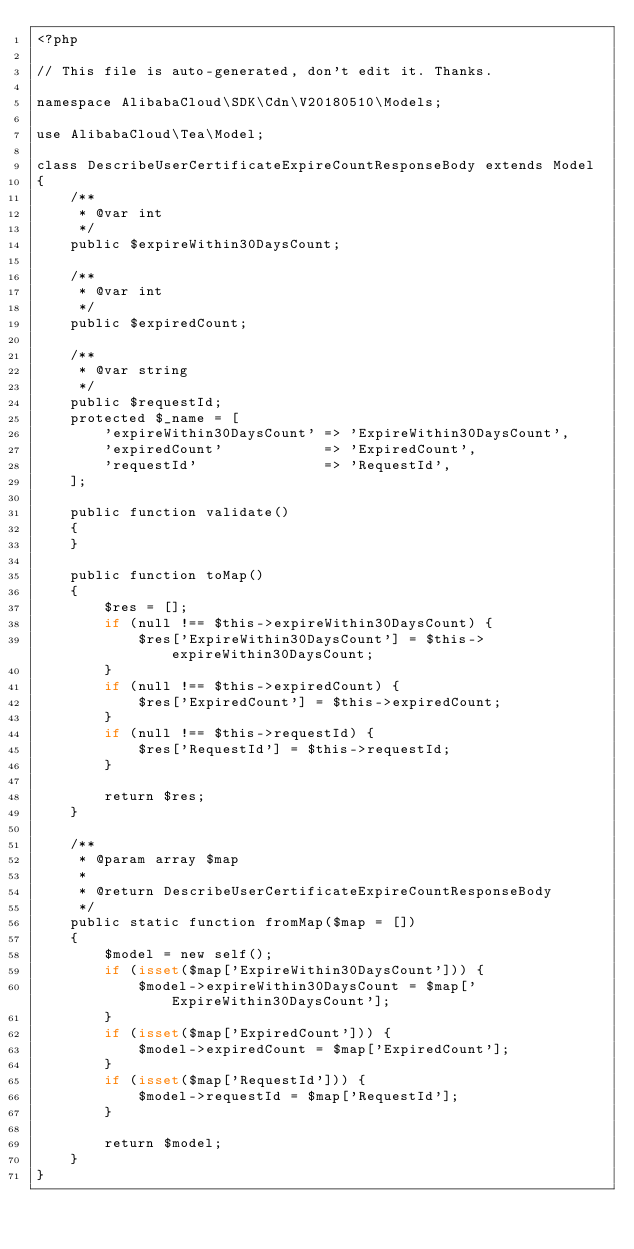<code> <loc_0><loc_0><loc_500><loc_500><_PHP_><?php

// This file is auto-generated, don't edit it. Thanks.

namespace AlibabaCloud\SDK\Cdn\V20180510\Models;

use AlibabaCloud\Tea\Model;

class DescribeUserCertificateExpireCountResponseBody extends Model
{
    /**
     * @var int
     */
    public $expireWithin30DaysCount;

    /**
     * @var int
     */
    public $expiredCount;

    /**
     * @var string
     */
    public $requestId;
    protected $_name = [
        'expireWithin30DaysCount' => 'ExpireWithin30DaysCount',
        'expiredCount'            => 'ExpiredCount',
        'requestId'               => 'RequestId',
    ];

    public function validate()
    {
    }

    public function toMap()
    {
        $res = [];
        if (null !== $this->expireWithin30DaysCount) {
            $res['ExpireWithin30DaysCount'] = $this->expireWithin30DaysCount;
        }
        if (null !== $this->expiredCount) {
            $res['ExpiredCount'] = $this->expiredCount;
        }
        if (null !== $this->requestId) {
            $res['RequestId'] = $this->requestId;
        }

        return $res;
    }

    /**
     * @param array $map
     *
     * @return DescribeUserCertificateExpireCountResponseBody
     */
    public static function fromMap($map = [])
    {
        $model = new self();
        if (isset($map['ExpireWithin30DaysCount'])) {
            $model->expireWithin30DaysCount = $map['ExpireWithin30DaysCount'];
        }
        if (isset($map['ExpiredCount'])) {
            $model->expiredCount = $map['ExpiredCount'];
        }
        if (isset($map['RequestId'])) {
            $model->requestId = $map['RequestId'];
        }

        return $model;
    }
}
</code> 